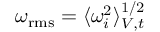Convert formula to latex. <formula><loc_0><loc_0><loc_500><loc_500>\omega _ { r m s } = \langle \omega _ { i } ^ { 2 } \rangle _ { V , t } ^ { 1 / 2 }</formula> 